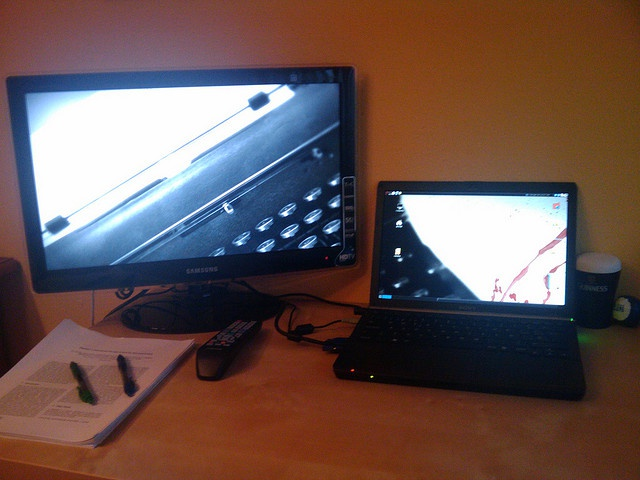Describe the objects in this image and their specific colors. I can see tv in brown, white, black, navy, and blue tones, laptop in brown, black, white, navy, and blue tones, book in brown and black tones, cup in brown, black, and gray tones, and remote in black, maroon, and brown tones in this image. 